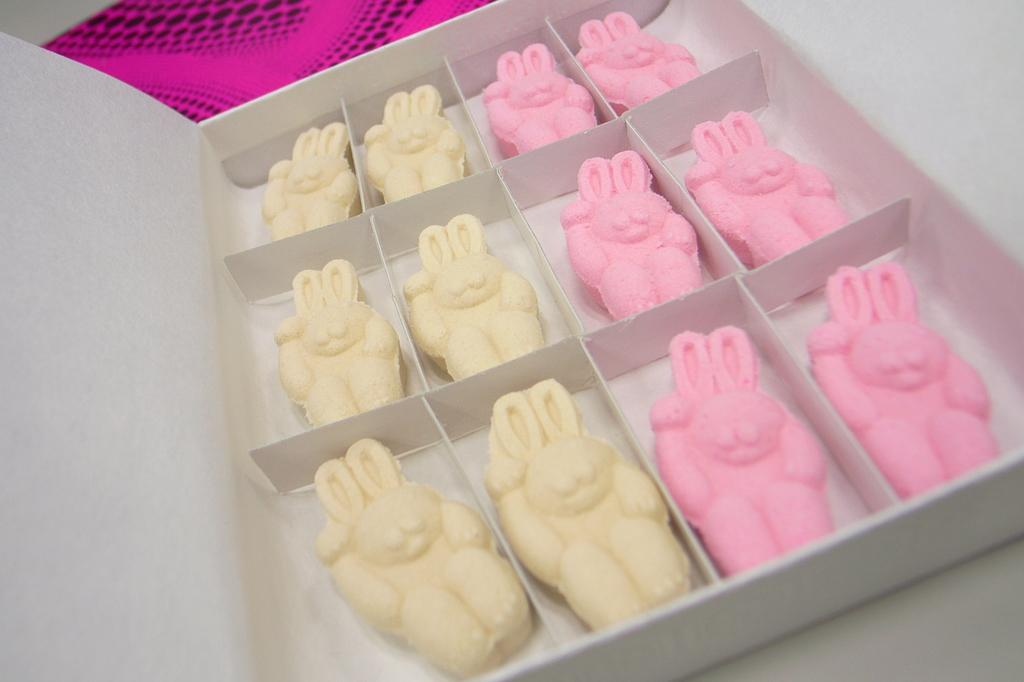What is inside the box that is visible in the image? There are food items in a box in the image. Can you describe the object on the table in the image? Unfortunately, the facts provided do not give enough information to describe the object on the table. What type of bucket is used to serve the eggnog in the image? There is no bucket or eggnog present in the image. 